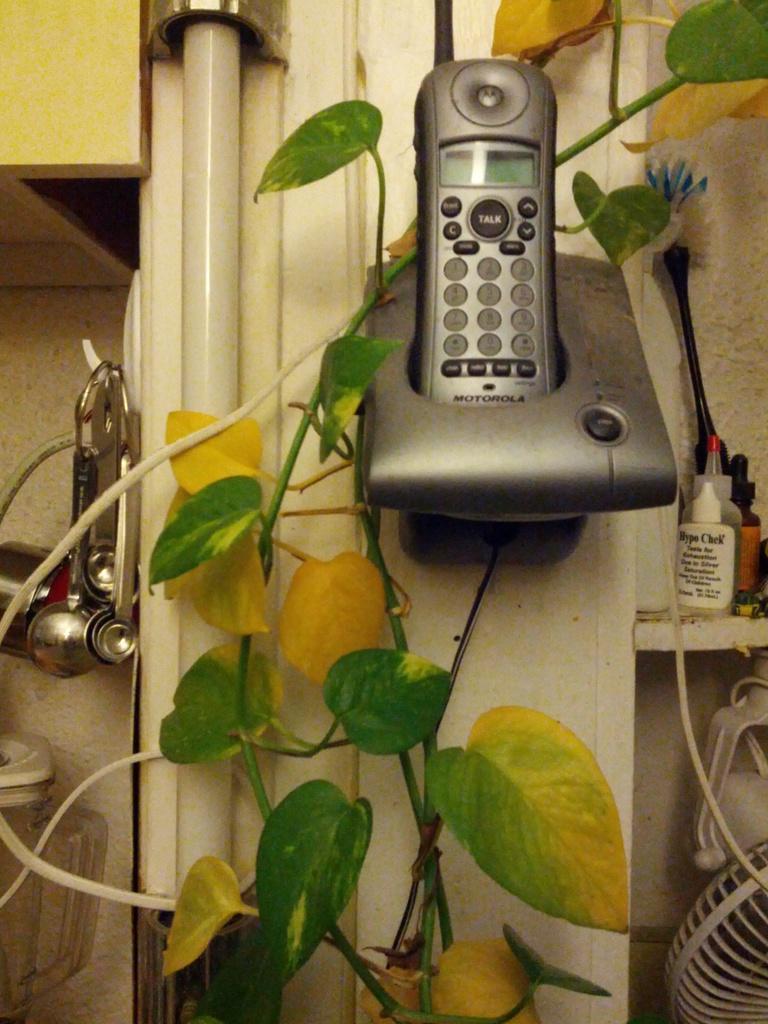In one or two sentences, can you explain what this image depicts? This image is taken indoors. In the background there is a wall and there is a pipeline. On the left side of the image there are a few objects. There is a wire. On the right side of the image there is a wall. There are a few things on the shelf and there is a fan. There is an object. In the middle of the image there is a landline phone and there is a plant with stems and leaves. 